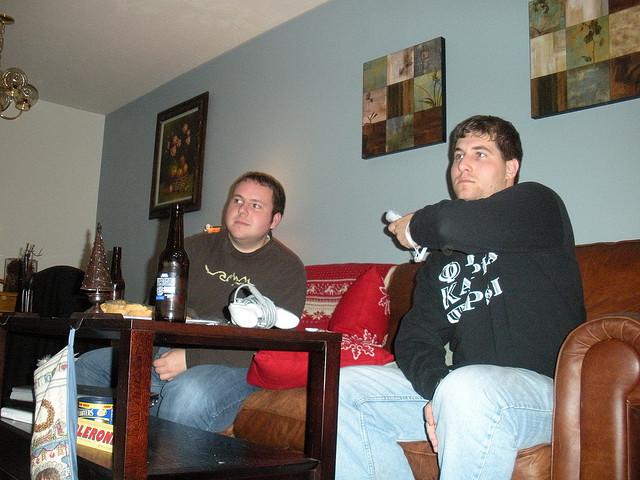How many things are hanging on the wall?
Keep it brief. 3. Are the people old?
Write a very short answer. No. What era is the light fixture on the ceiling from?
Give a very brief answer. Victorian. What kind of bottle is on the corner of the table?
Give a very brief answer. Beer. 